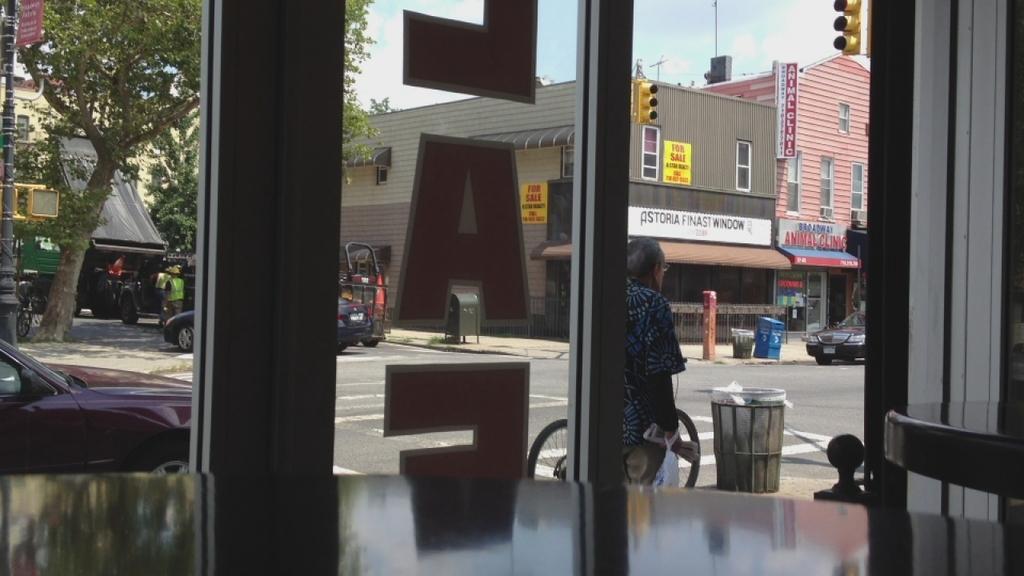How would you summarize this image in a sentence or two? In this image we can see glass windows and tables. Through the glass window we can see buildings, traffic lights, vehicles, trees, dustbins, boards and sky. 